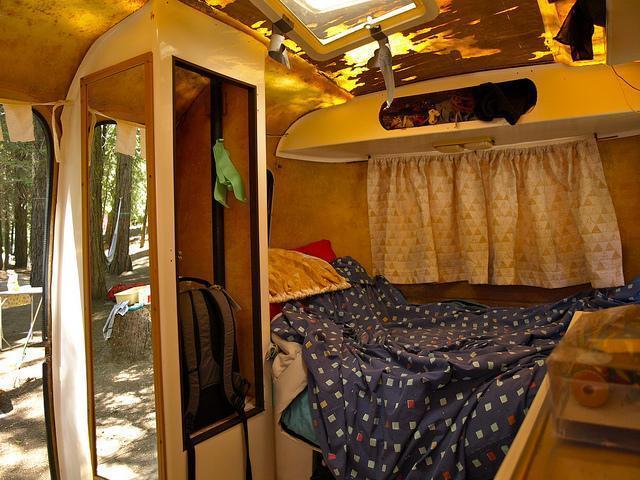How many skateboard wheels are there?
Give a very brief answer. 0. 